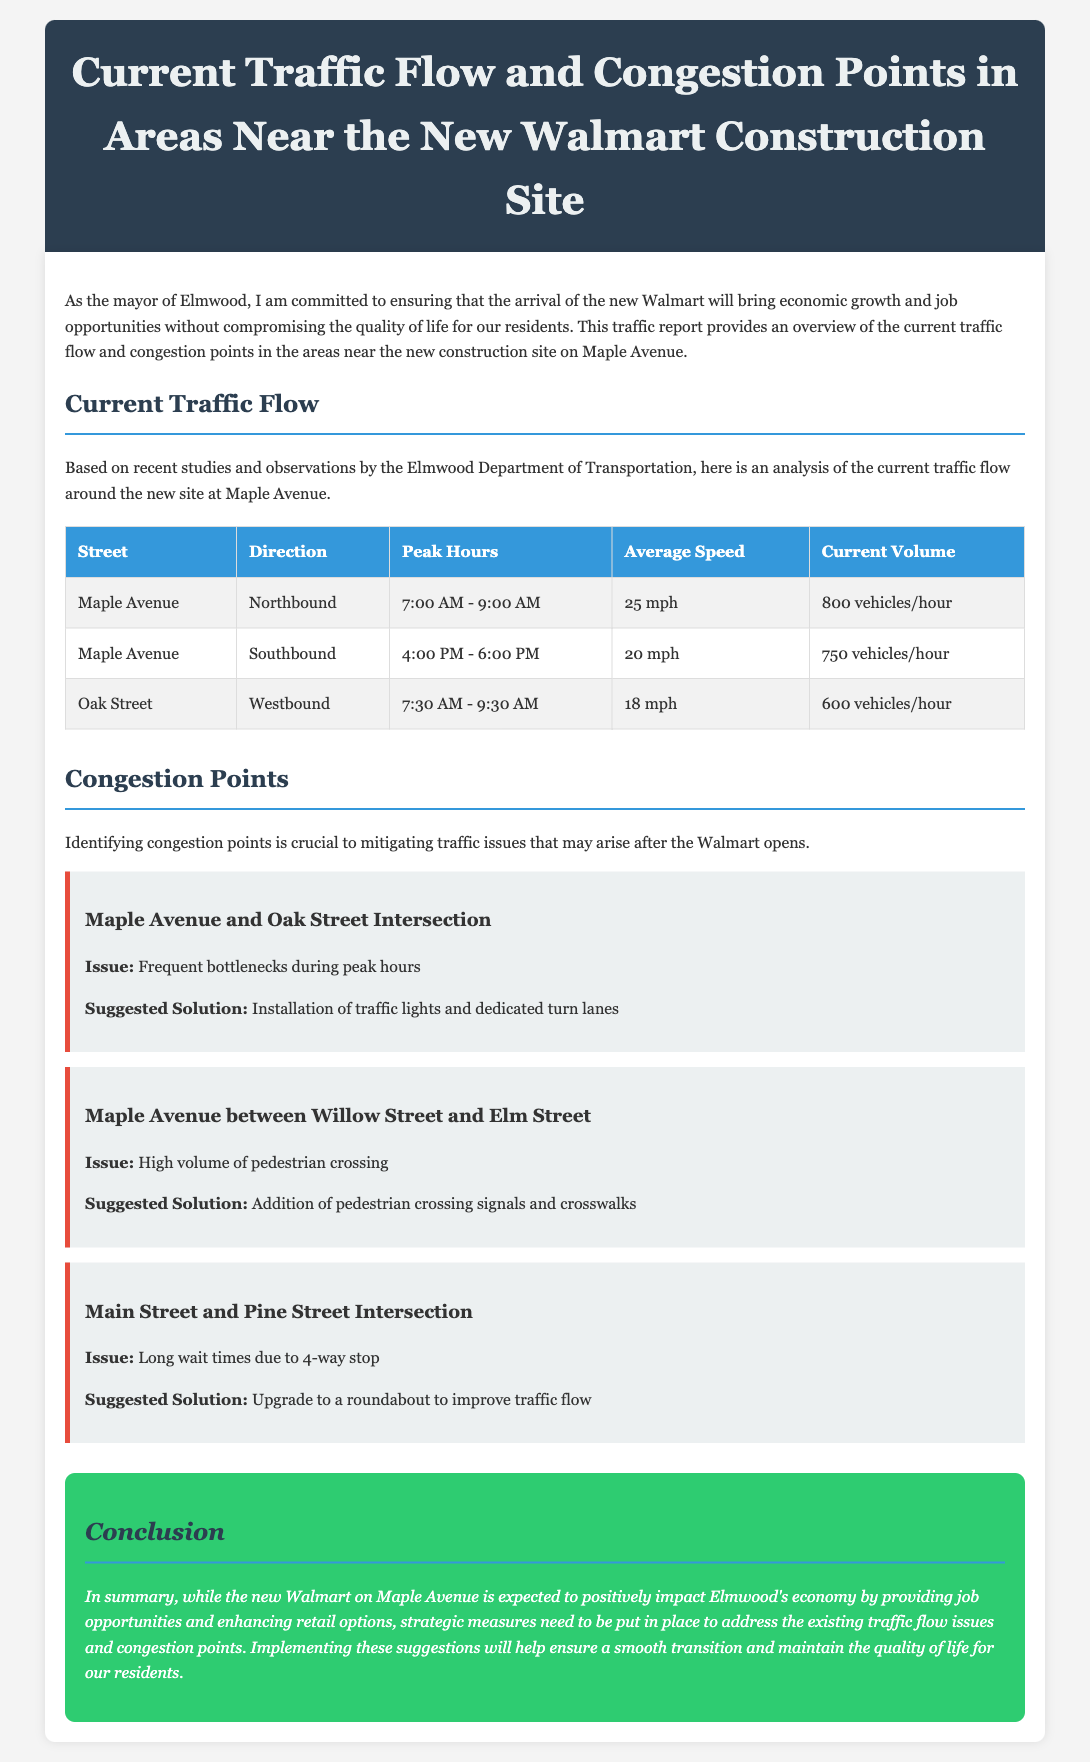what is the peak hour for southbound traffic on Maple Avenue? The peak hour for southbound traffic on Maple Avenue is from 4:00 PM to 6:00 PM.
Answer: 4:00 PM - 6:00 PM what is the average speed of northbound traffic on Maple Avenue? The average speed of northbound traffic on Maple Avenue is stated in the traffic flow table.
Answer: 25 mph how many vehicles per hour currently travel southbound on Maple Avenue? The current volume of southbound traffic on Maple Avenue is provided in the document.
Answer: 750 vehicles/hour what is one suggested solution for the congestion at the Maple Avenue and Oak Street intersection? The document lists suggested solutions for various congestion points, including the one for Maple Avenue and Oak Street.
Answer: Installation of traffic lights and dedicated turn lanes what issue is reported for Maple Avenue between Willow Street and Elm Street? The document describes issues at various congestion points, specifically mentioning this street segment.
Answer: High volume of pedestrian crossing how many vehicles per hour are currently traveling westbound on Oak Street? The traffic flow table provides current volume information for vehicles on Oak Street.
Answer: 600 vehicles/hour what solution does the report recommend for the Main Street and Pine Street intersection? The document specifies a recommendation aimed at improving traffic flow at this intersection.
Answer: Upgrade to a roundabout what is the total number of congestion points identified in the report? The report lists multiple congestion points which need addressing; counting them gives the total.
Answer: 3 what time does the peak hour for westbound traffic on Oak Street occur? The traffic flow details provide the specific timing for peak hours of different streets.
Answer: 7:30 AM - 9:30 AM 